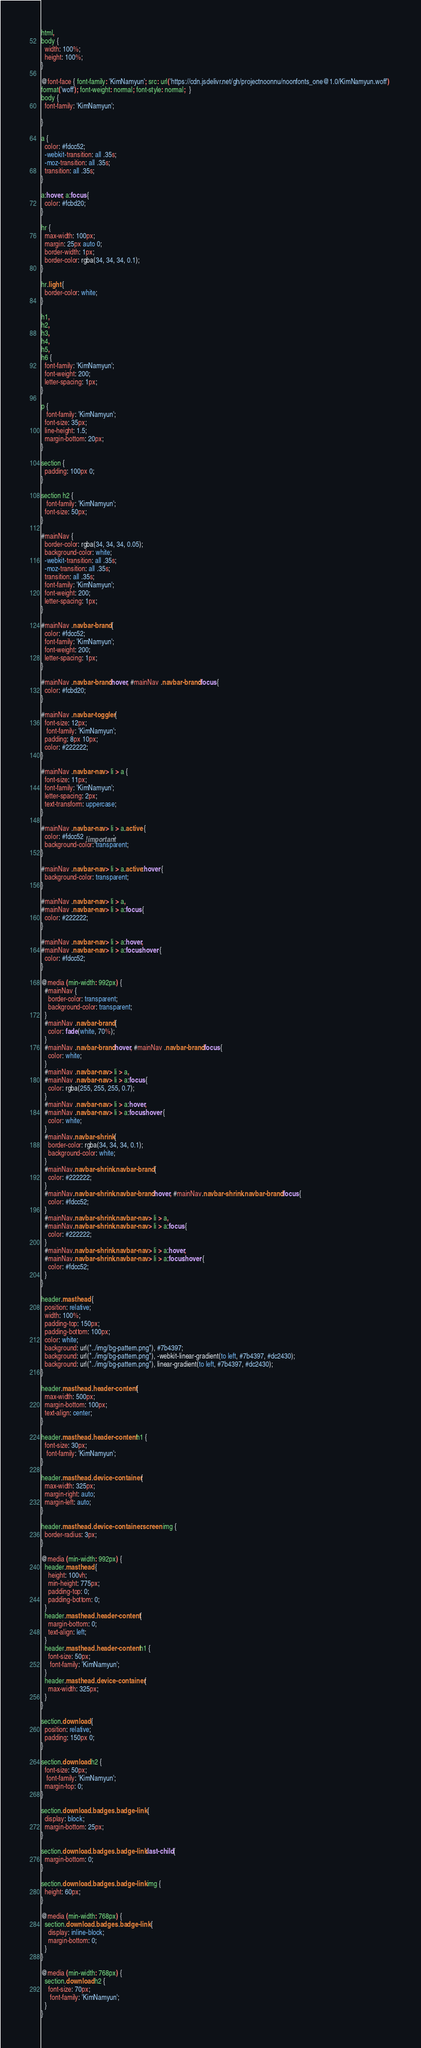Convert code to text. <code><loc_0><loc_0><loc_500><loc_500><_CSS_>html,
body {
  width: 100%;
  height: 100%;
}

@font-face { font-family: 'KimNamyun'; src: url('https://cdn.jsdelivr.net/gh/projectnoonnu/noonfonts_one@1.0/KimNamyun.woff') 
format('woff'); font-weight: normal; font-style: normal;  }
body {
  font-family: 'KimNamyun';
  
}

a {
  color: #fdcc52;
  -webkit-transition: all .35s;
  -moz-transition: all .35s;
  transition: all .35s;
}

a:hover, a:focus {
  color: #fcbd20;
}

hr {
  max-width: 100px;
  margin: 25px auto 0;
  border-width: 1px;
  border-color: rgba(34, 34, 34, 0.1);
}

hr.light {
  border-color: white;
}

h1,
h2,
h3,
h4,
h5,
h6 {
  font-family: 'KimNamyun';
  font-weight: 200;
  letter-spacing: 1px;
}

p {
   font-family: 'KimNamyun';
  font-size: 35px;
  line-height: 1.5;
  margin-bottom: 20px;
}

section {
  padding: 100px 0;
}

section h2 {
   font-family: 'KimNamyun';
  font-size: 50px;
}

#mainNav {
  border-color: rgba(34, 34, 34, 0.05);
  background-color: white;
  -webkit-transition: all .35s;
  -moz-transition: all .35s;
  transition: all .35s;
  font-family: 'KimNamyun';
  font-weight: 200;
  letter-spacing: 1px;
}

#mainNav .navbar-brand {
  color: #fdcc52;
  font-family: 'KimNamyun';
  font-weight: 200;
  letter-spacing: 1px;
}

#mainNav .navbar-brand:hover, #mainNav .navbar-brand:focus {
  color: #fcbd20;
}

#mainNav .navbar-toggler {
  font-size: 12px;
   font-family: 'KimNamyun';
  padding: 8px 10px;
  color: #222222;
}

#mainNav .navbar-nav > li > a {
  font-size: 11px;
  font-family: 'KimNamyun';
  letter-spacing: 2px;
  text-transform: uppercase;
}

#mainNav .navbar-nav > li > a.active {
  color: #fdcc52 !important;
  background-color: transparent;
}

#mainNav .navbar-nav > li > a.active:hover {
  background-color: transparent;
}

#mainNav .navbar-nav > li > a,
#mainNav .navbar-nav > li > a:focus {
  color: #222222;
}

#mainNav .navbar-nav > li > a:hover,
#mainNav .navbar-nav > li > a:focus:hover {
  color: #fdcc52;
}

@media (min-width: 992px) {
  #mainNav {
    border-color: transparent;
    background-color: transparent;
  }
  #mainNav .navbar-brand {
    color: fade(white, 70%);
  }
  #mainNav .navbar-brand:hover, #mainNav .navbar-brand:focus {
    color: white;
  }
  #mainNav .navbar-nav > li > a,
  #mainNav .navbar-nav > li > a:focus {
    color: rgba(255, 255, 255, 0.7);
  }
  #mainNav .navbar-nav > li > a:hover,
  #mainNav .navbar-nav > li > a:focus:hover {
    color: white;
  }
  #mainNav.navbar-shrink {
    border-color: rgba(34, 34, 34, 0.1);
    background-color: white;
  }
  #mainNav.navbar-shrink .navbar-brand {
    color: #222222;
  }
  #mainNav.navbar-shrink .navbar-brand:hover, #mainNav.navbar-shrink .navbar-brand:focus {
    color: #fdcc52;
  }
  #mainNav.navbar-shrink .navbar-nav > li > a,
  #mainNav.navbar-shrink .navbar-nav > li > a:focus {
    color: #222222;
  }
  #mainNav.navbar-shrink .navbar-nav > li > a:hover,
  #mainNav.navbar-shrink .navbar-nav > li > a:focus:hover {
    color: #fdcc52;
  }
}

header.masthead {
  position: relative;
  width: 100%;
  padding-top: 150px;
  padding-bottom: 100px;
  color: white;
  background: url("../img/bg-pattern.png"), #7b4397;
  background: url("../img/bg-pattern.png"), -webkit-linear-gradient(to left, #7b4397, #dc2430);
  background: url("../img/bg-pattern.png"), linear-gradient(to left, #7b4397, #dc2430);
}

header.masthead .header-content {
  max-width: 500px;
  margin-bottom: 100px;
  text-align: center;
}

header.masthead .header-content h1 {
  font-size: 30px;
   font-family: 'KimNamyun';
}

header.masthead .device-container {
  max-width: 325px;
  margin-right: auto;
  margin-left: auto;
}

header.masthead .device-container .screen img {
  border-radius: 3px;
}

@media (min-width: 992px) {
  header.masthead {
    height: 100vh;
    min-height: 775px;
    padding-top: 0;
    padding-bottom: 0;
  }
  header.masthead .header-content {
    margin-bottom: 0;
    text-align: left;
  }
  header.masthead .header-content h1 {
    font-size: 50px;
     font-family: 'KimNamyun';
  }
  header.masthead .device-container {
    max-width: 325px;
  }
}

section.download {
  position: relative;
  padding: 150px 0;
}

section.download h2 {
  font-size: 50px;
   font-family: 'KimNamyun';
  margin-top: 0;
}

section.download .badges .badge-link {
  display: block;
  margin-bottom: 25px;
}

section.download .badges .badge-link:last-child {
  margin-bottom: 0;
}

section.download .badges .badge-link img {
  height: 60px;
}

@media (min-width: 768px) {
  section.download .badges .badge-link {
    display: inline-block;
    margin-bottom: 0;
  }
}

@media (min-width: 768px) {
  section.download h2 {
    font-size: 70px;
     font-family: 'KimNamyun';
  }
}
</code> 